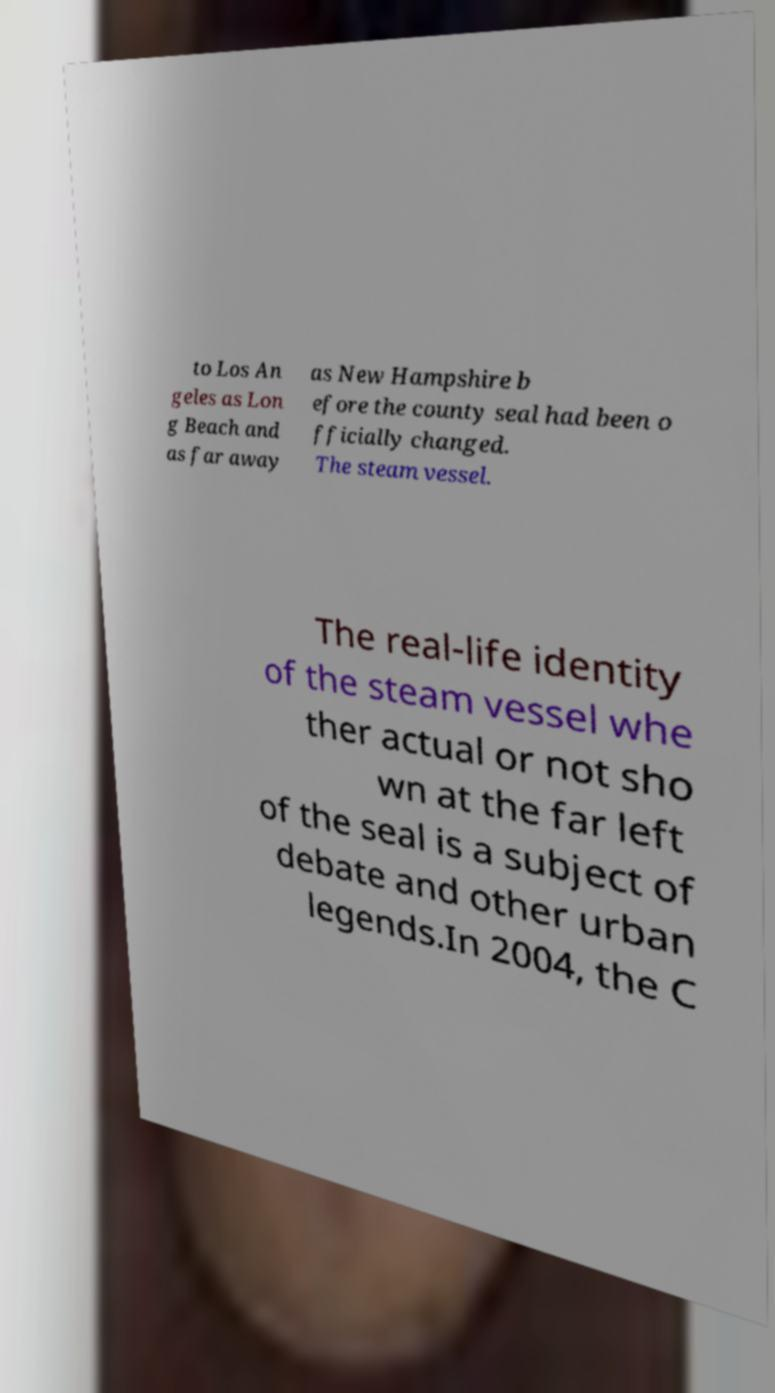Could you assist in decoding the text presented in this image and type it out clearly? to Los An geles as Lon g Beach and as far away as New Hampshire b efore the county seal had been o fficially changed. The steam vessel. The real-life identity of the steam vessel whe ther actual or not sho wn at the far left of the seal is a subject of debate and other urban legends.In 2004, the C 